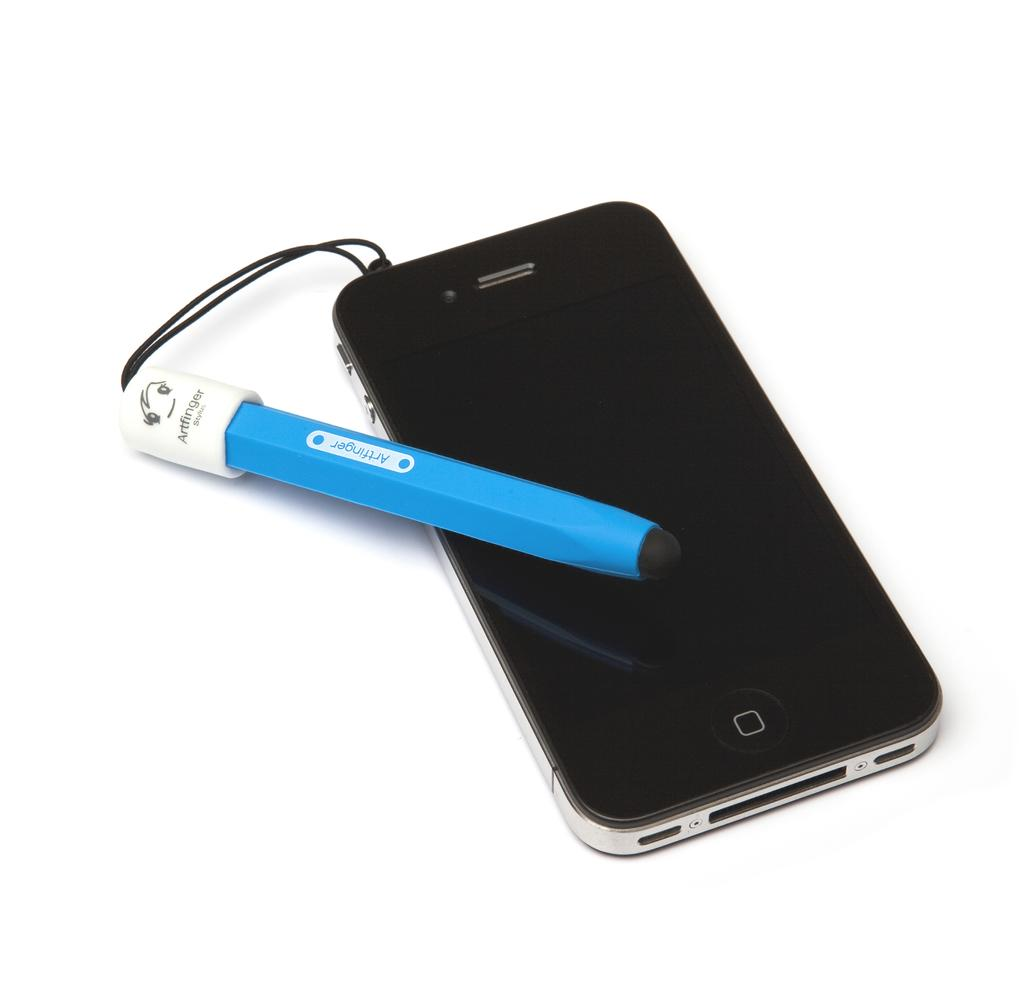Provide a one-sentence caption for the provided image. An apple branded iphone with an artfinger blue attachment hangin off of it. 